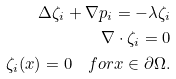Convert formula to latex. <formula><loc_0><loc_0><loc_500><loc_500>\Delta \zeta _ { i } + \nabla p _ { i } = - \lambda \zeta _ { i } \\ \nabla \cdot \zeta _ { i } = 0 \\ \zeta _ { i } ( x ) = 0 \quad f o r x \in \partial \Omega .</formula> 